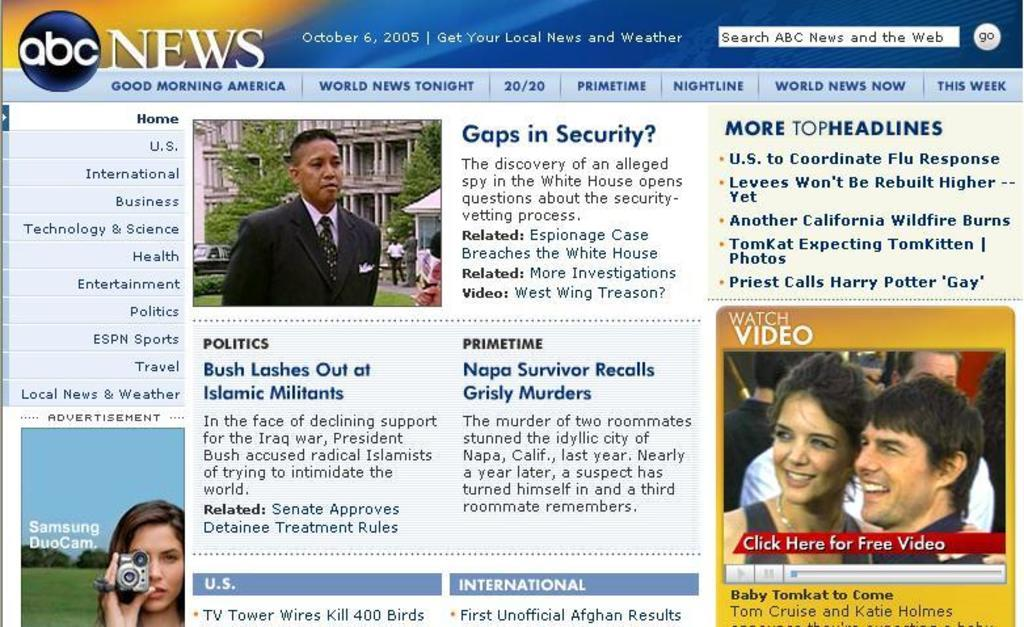What type of page is shown in the image? The image is of a website's home page. What can be found on the home page? There are words and pictures on the home page. What type of clothing are the girls wearing in the image? There are no girls present in the image; it is a website's home page with words and pictures. 